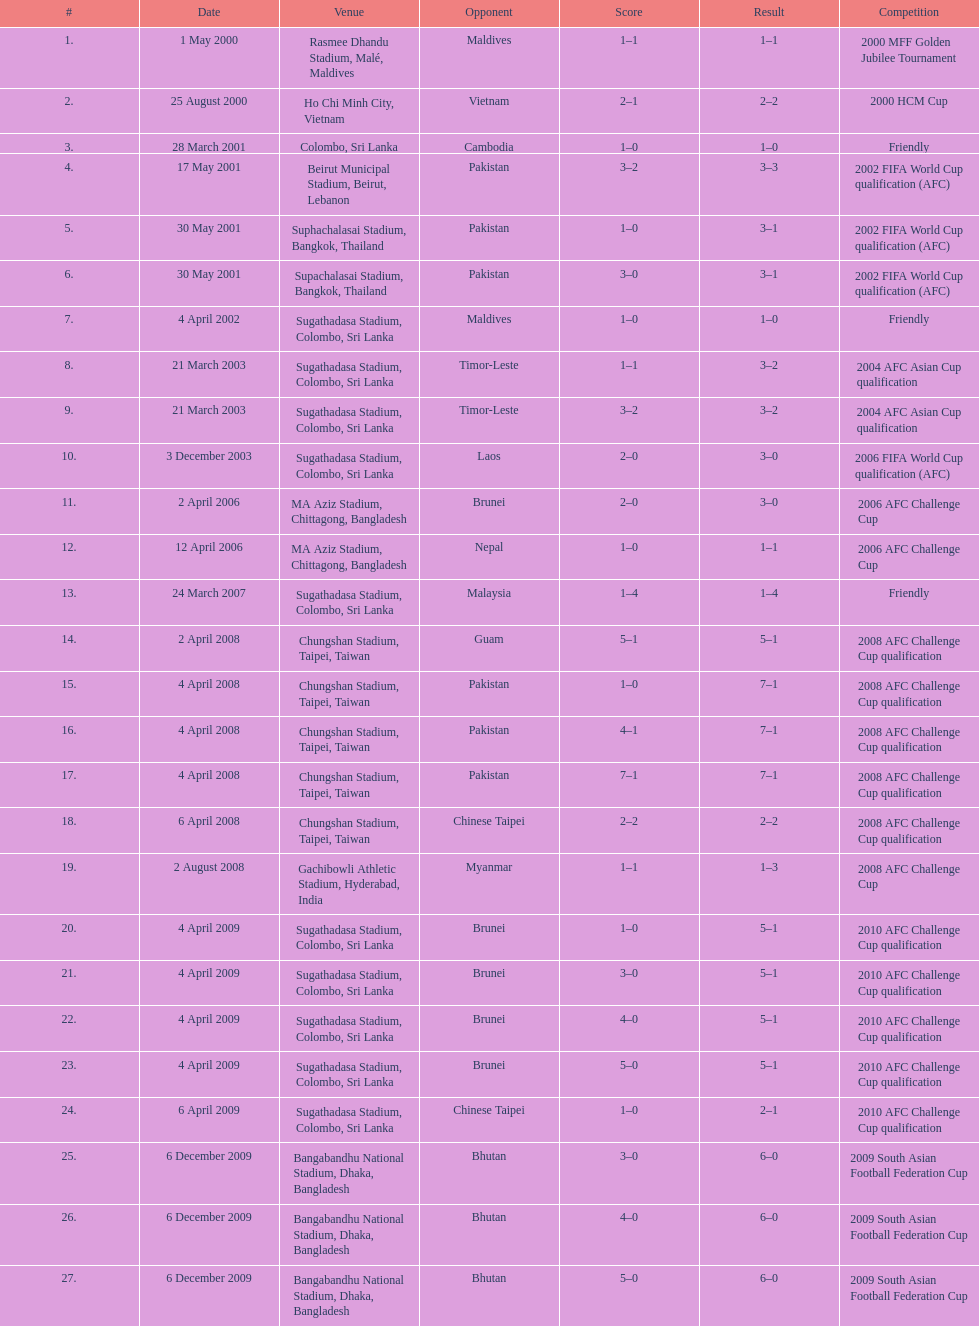What is the highest-ranked venue in the chart? Rasmee Dhandu Stadium, Malé, Maldives. 